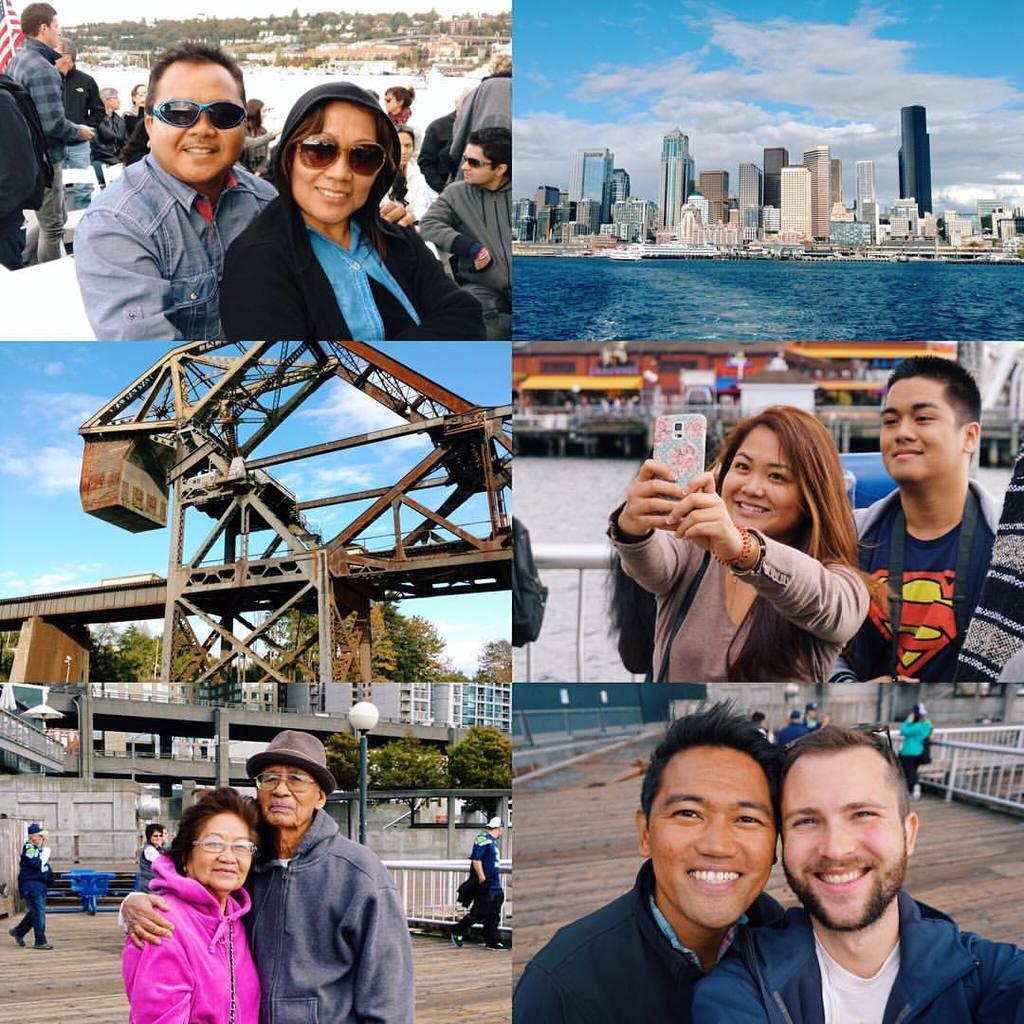Can you describe this image briefly? In this picture I can see the collage pictures where I can see number of people and I see few of them are smiling and on the top left picture I see the snow and I see few photos, where I can see number of buildings, water and the sky. 